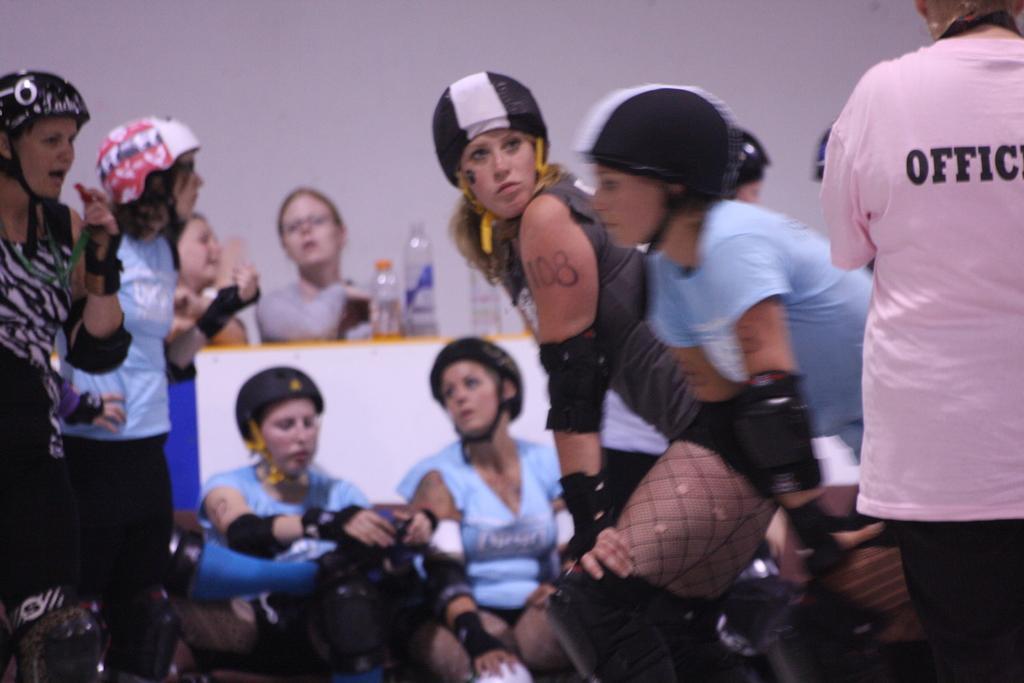In one or two sentences, can you explain what this image depicts? In this picture I can see a few people standing. I can see a few people sitting. I can see helmets. I can see bottles on the surface. 